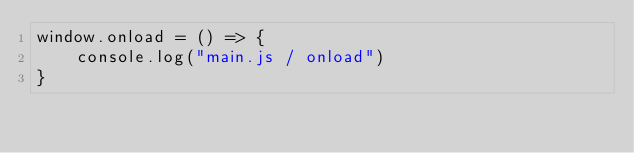<code> <loc_0><loc_0><loc_500><loc_500><_JavaScript_>window.onload = () => {
    console.log("main.js / onload")
}
</code> 